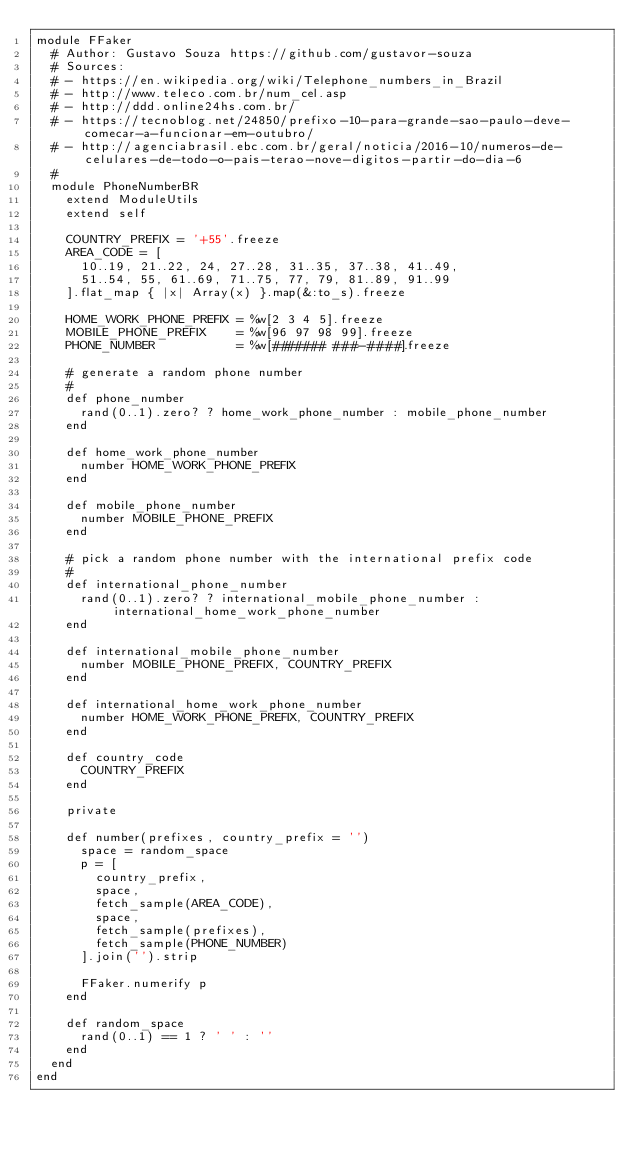<code> <loc_0><loc_0><loc_500><loc_500><_Ruby_>module FFaker
  # Author: Gustavo Souza https://github.com/gustavor-souza
  # Sources:
  # - https://en.wikipedia.org/wiki/Telephone_numbers_in_Brazil
  # - http://www.teleco.com.br/num_cel.asp
  # - http://ddd.online24hs.com.br/
  # - https://tecnoblog.net/24850/prefixo-10-para-grande-sao-paulo-deve-comecar-a-funcionar-em-outubro/
  # - http://agenciabrasil.ebc.com.br/geral/noticia/2016-10/numeros-de-celulares-de-todo-o-pais-terao-nove-digitos-partir-do-dia-6
  #
  module PhoneNumberBR
    extend ModuleUtils
    extend self

    COUNTRY_PREFIX = '+55'.freeze
    AREA_CODE = [
      10..19, 21..22, 24, 27..28, 31..35, 37..38, 41..49,
      51..54, 55, 61..69, 71..75, 77, 79, 81..89, 91..99
    ].flat_map { |x| Array(x) }.map(&:to_s).freeze

    HOME_WORK_PHONE_PREFIX = %w[2 3 4 5].freeze
    MOBILE_PHONE_PREFIX    = %w[96 97 98 99].freeze
    PHONE_NUMBER           = %w[####### ###-####].freeze

    # generate a random phone number
    #
    def phone_number
      rand(0..1).zero? ? home_work_phone_number : mobile_phone_number
    end

    def home_work_phone_number
      number HOME_WORK_PHONE_PREFIX
    end

    def mobile_phone_number
      number MOBILE_PHONE_PREFIX
    end

    # pick a random phone number with the international prefix code
    #
    def international_phone_number
      rand(0..1).zero? ? international_mobile_phone_number : international_home_work_phone_number
    end

    def international_mobile_phone_number
      number MOBILE_PHONE_PREFIX, COUNTRY_PREFIX
    end

    def international_home_work_phone_number
      number HOME_WORK_PHONE_PREFIX, COUNTRY_PREFIX
    end

    def country_code
      COUNTRY_PREFIX
    end

    private

    def number(prefixes, country_prefix = '')
      space = random_space
      p = [
        country_prefix,
        space,
        fetch_sample(AREA_CODE),
        space,
        fetch_sample(prefixes),
        fetch_sample(PHONE_NUMBER)
      ].join('').strip

      FFaker.numerify p
    end

    def random_space
      rand(0..1) == 1 ? ' ' : ''
    end
  end
end
</code> 